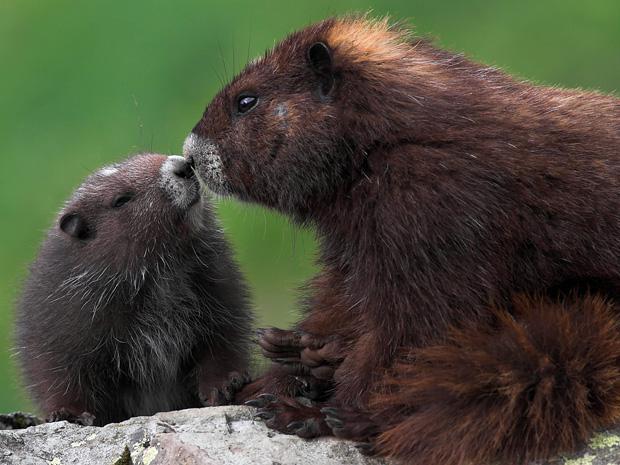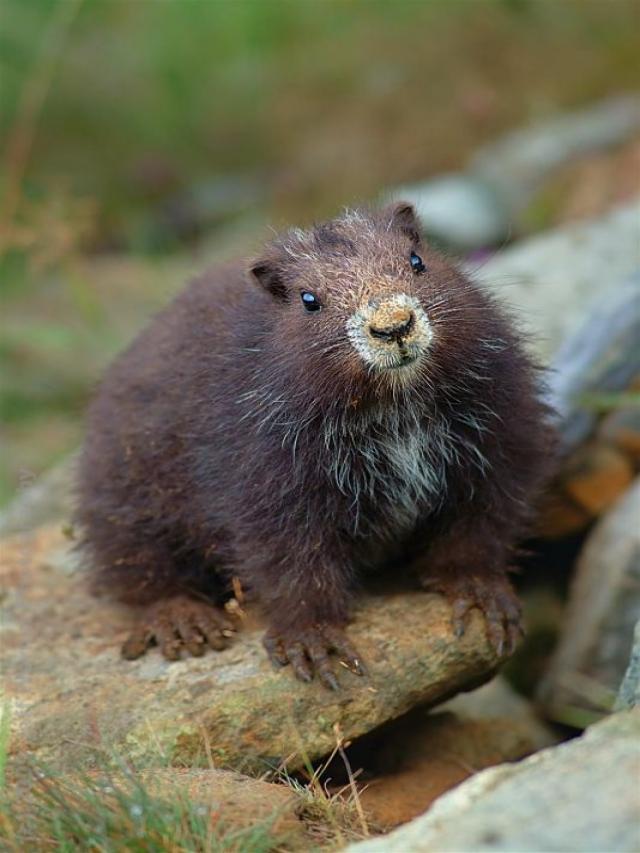The first image is the image on the left, the second image is the image on the right. For the images displayed, is the sentence "One image contains twice as many marmots as the other image." factually correct? Answer yes or no. Yes. The first image is the image on the left, the second image is the image on the right. For the images shown, is this caption "The left and right image contains a total of three groundhogs." true? Answer yes or no. Yes. 